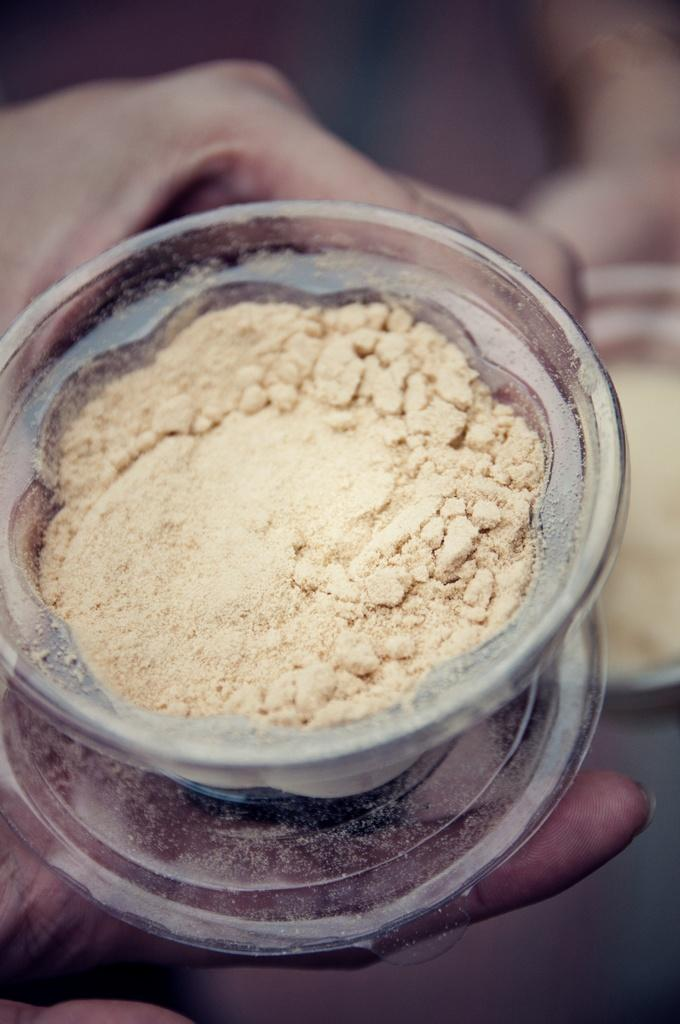What is the main subject of the image? There is a human in the image. What is the human holding in the image? The human is holding a glass bowl in the image. What is inside the glass bowl? Flour is present in the glass bowl. What type of lawyer is depicted in the image? There is no lawyer present in the image; it features a human holding a glass bowl with flour. What happens when the human smashes the pot in the image? There is no pot present in the image, and the human is not shown smashing anything. 